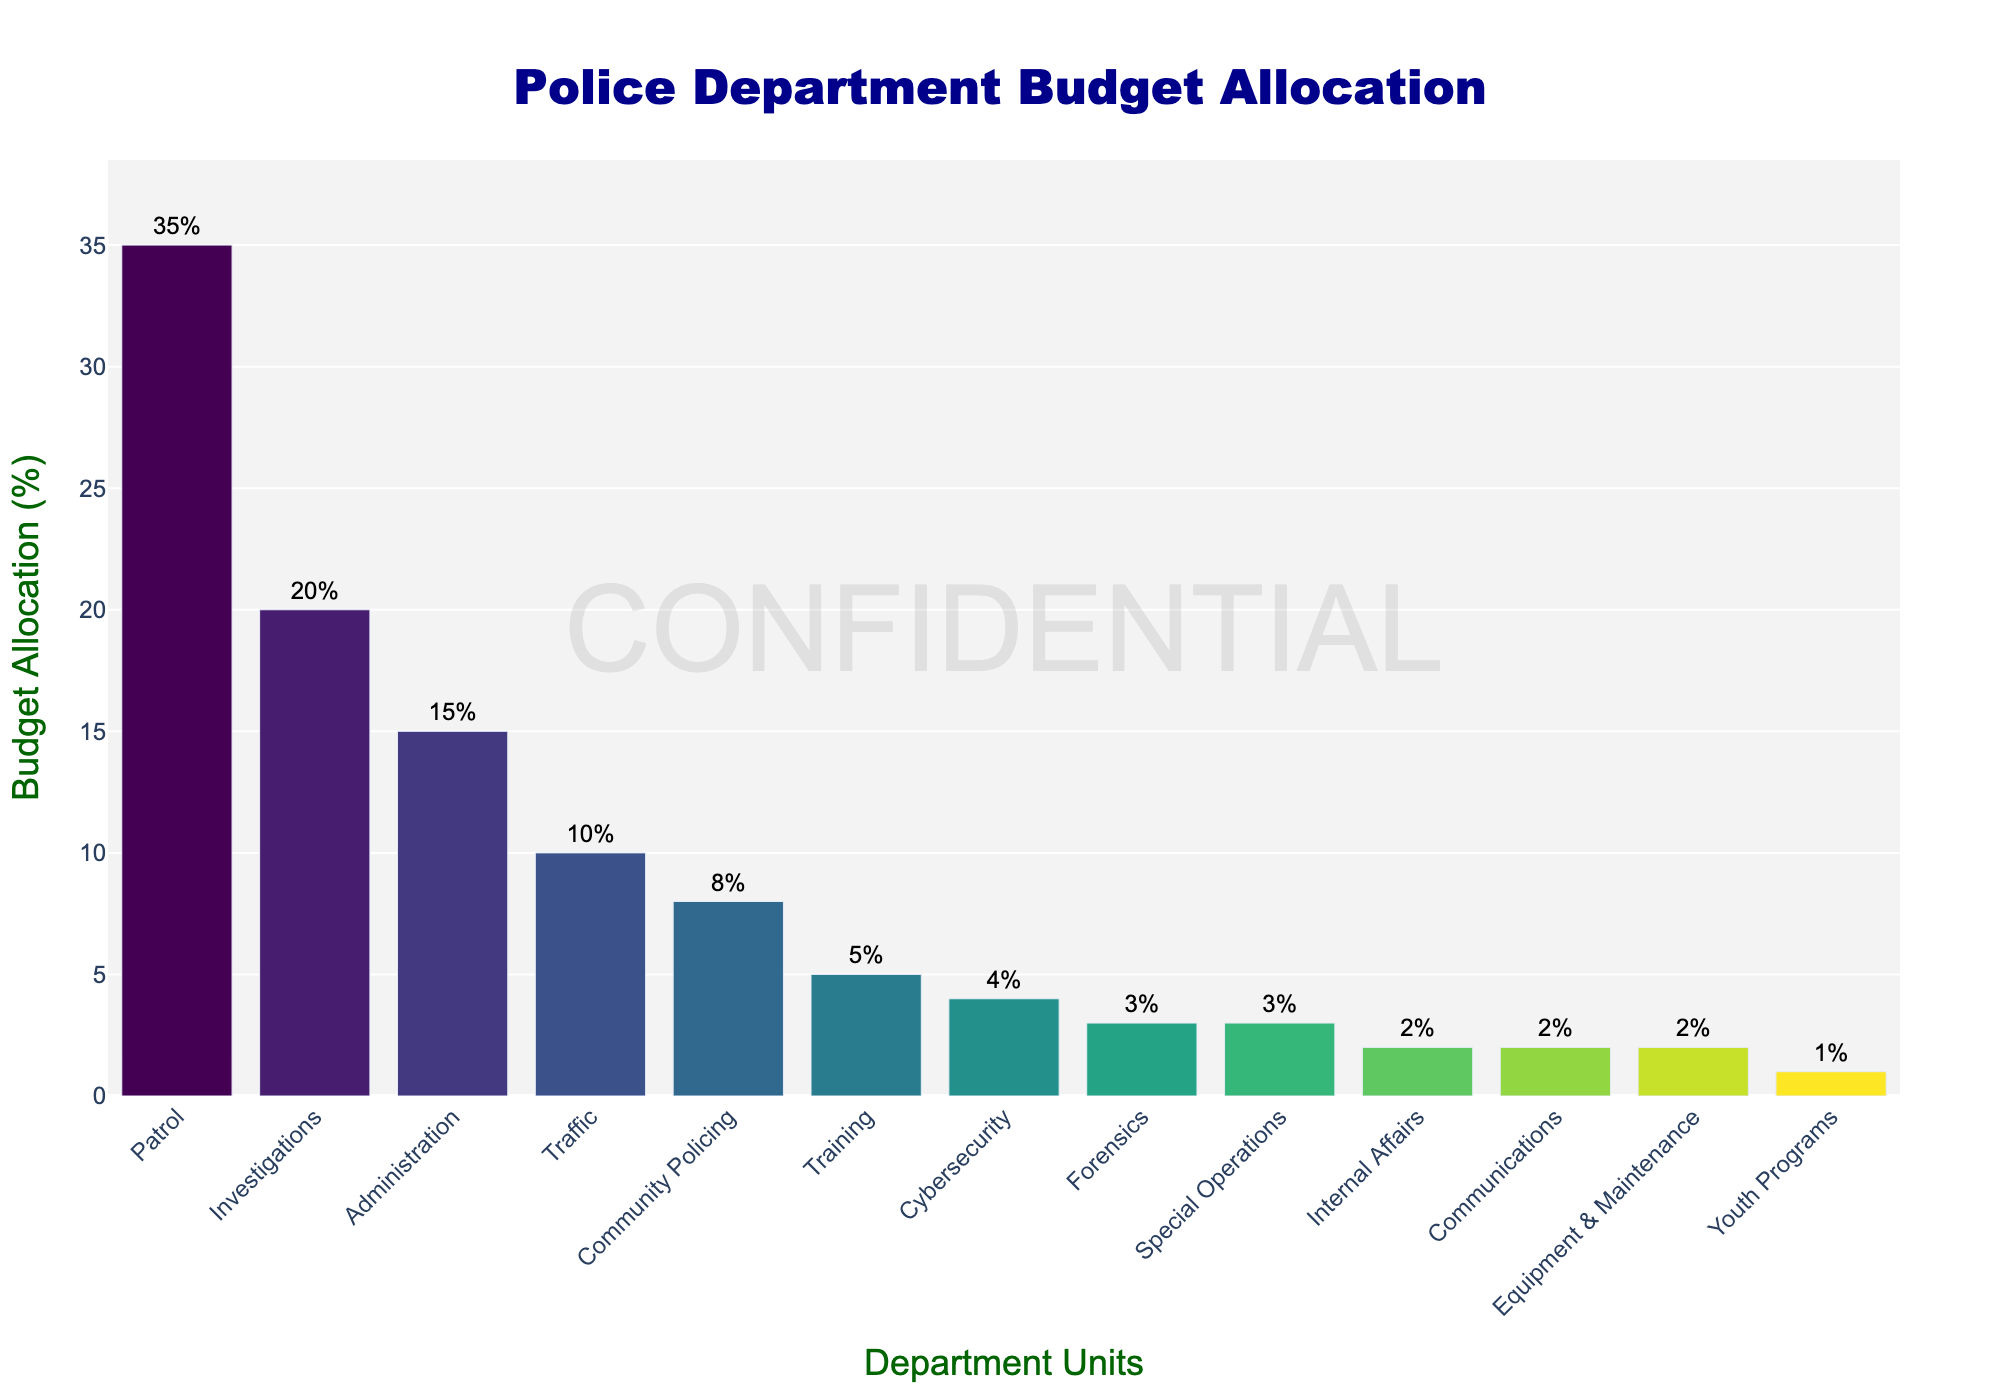What is the unit with the highest budget allocation and what percentage is it? To determine the unit with the highest budget allocation, look for the tallest bar in the bar chart. The text label above this bar will give the name of the unit and the percentage.
Answer: Patrol, 35% Which unit has a lower budget allocation: Cybersecurity or Training? First, find the bars representing Cybersecurity and Training. Compare the heights of these two bars or read the text labels above them to see which one is lower.
Answer: Cybersecurity What is the total budget allocation percentage for Community Policing, Training, and Youth Programs combined? Locate the bars for Community Policing, Training, and Youth Programs. Sum their budget percentages: 8% (Community Policing) + 5% (Training) + 1% (Youth Programs).
Answer: 14% How much more budget allocation does Patrol have compared to Investigations? Find the bars for Patrol and Investigations. Subtract the percentage for Investigations from the percentage for Patrol: 35% (Patrol) - 20% (Investigations).
Answer: 15% Which units have the same budget allocation percentage? Check for bars that are equal in height or have the same text labels above them. Identify any units that share the same allocation percentage.
Answer: Special Operations, Communications, Equipment & Maintenance (all 2%) What is the average budget allocation percentage for the Traffic, Cybersecurity, and Forensics units? Locate the bars for Traffic, Cybersecurity, and Forensics. Sum their percentages and divide by the number of units: (10% + 4% + 3%) / 3.
Answer: 5.67% How does the budget allocation for Cybersecurity compare to that for Community Policing? Find and compare the bars for Cybersecurity and Community Policing by checking their heights or text labels. Determine which is higher and by how much.
Answer: Community Policing has 4% more than Cybersecurity What percentage of the budget is allocated to units with less than 5% each? Identify bars with percentages less than 5%, then sum their values: 4% (Cybersecurity) + 3% (Forensics) + 3% (Special Operations) + 2% (Internal Affairs) + 2% (Communications) + 2% (Equipment & Maintenance) + 1% (Youth Programs).
Answer: 17% 